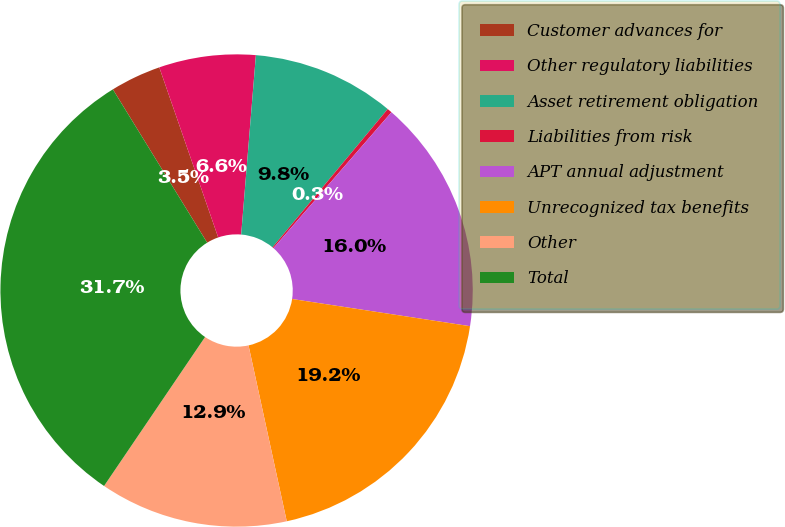<chart> <loc_0><loc_0><loc_500><loc_500><pie_chart><fcel>Customer advances for<fcel>Other regulatory liabilities<fcel>Asset retirement obligation<fcel>Liabilities from risk<fcel>APT annual adjustment<fcel>Unrecognized tax benefits<fcel>Other<fcel>Total<nl><fcel>3.47%<fcel>6.61%<fcel>9.75%<fcel>0.33%<fcel>16.03%<fcel>19.18%<fcel>12.89%<fcel>31.74%<nl></chart> 